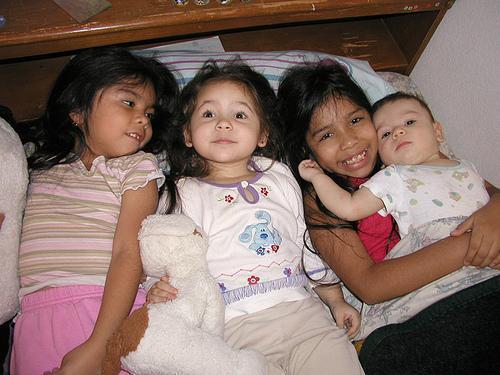How many children are laying in the bed?
Give a very brief answer. 4. How many children are smiling?
Give a very brief answer. 2. How many people are there?
Give a very brief answer. 4. How many horses are on the beach?
Give a very brief answer. 0. 